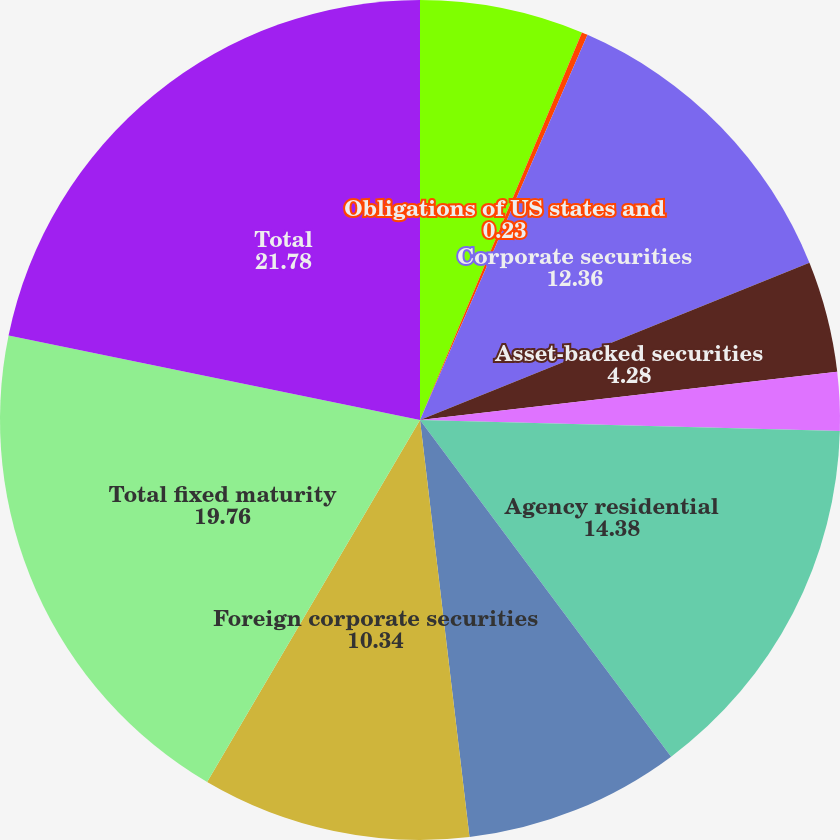Convert chart to OTSL. <chart><loc_0><loc_0><loc_500><loc_500><pie_chart><fcel>US government agencies and<fcel>Obligations of US states and<fcel>Corporate securities<fcel>Asset-backed securities<fcel>Commercial<fcel>Agency residential<fcel>Foreign government securities<fcel>Foreign corporate securities<fcel>Total fixed maturity<fcel>Total<nl><fcel>6.3%<fcel>0.23%<fcel>12.36%<fcel>4.28%<fcel>2.25%<fcel>14.38%<fcel>8.32%<fcel>10.34%<fcel>19.76%<fcel>21.78%<nl></chart> 